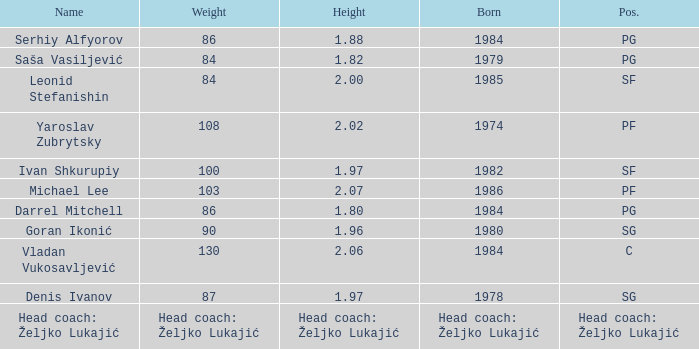What is the weight of the player with a height of 2.00m? 84.0. Can you give me this table as a dict? {'header': ['Name', 'Weight', 'Height', 'Born', 'Pos.'], 'rows': [['Serhiy Alfyorov', '86', '1.88', '1984', 'PG'], ['Saša Vasiljević', '84', '1.82', '1979', 'PG'], ['Leonid Stefanishin', '84', '2.00', '1985', 'SF'], ['Yaroslav Zubrytsky', '108', '2.02', '1974', 'PF'], ['Ivan Shkurupiy', '100', '1.97', '1982', 'SF'], ['Michael Lee', '103', '2.07', '1986', 'PF'], ['Darrel Mitchell', '86', '1.80', '1984', 'PG'], ['Goran Ikonić', '90', '1.96', '1980', 'SG'], ['Vladan Vukosavljević', '130', '2.06', '1984', 'C'], ['Denis Ivanov', '87', '1.97', '1978', 'SG'], ['Head coach: Željko Lukajić', 'Head coach: Željko Lukajić', 'Head coach: Željko Lukajić', 'Head coach: Željko Lukajić', 'Head coach: Željko Lukajić']]} 